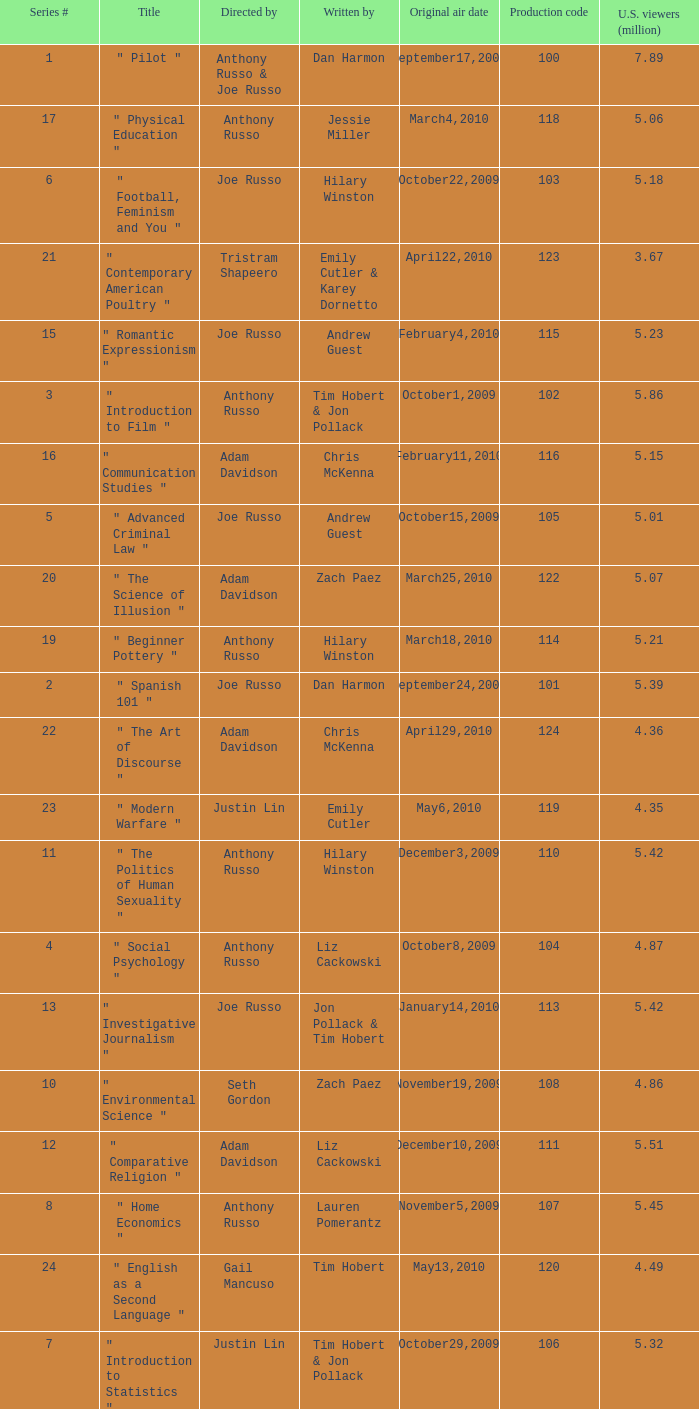What is the highest series # directed by ken whittingham? 18.0. 